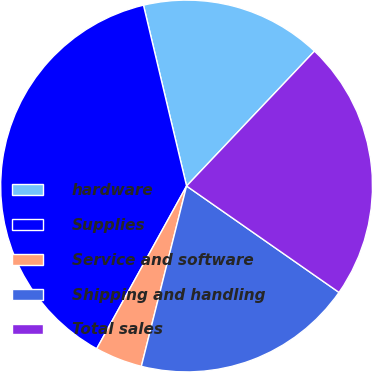Convert chart. <chart><loc_0><loc_0><loc_500><loc_500><pie_chart><fcel>hardware<fcel>Supplies<fcel>Service and software<fcel>Shipping and handling<fcel>Total sales<nl><fcel>15.8%<fcel>38.24%<fcel>4.12%<fcel>19.21%<fcel>22.62%<nl></chart> 